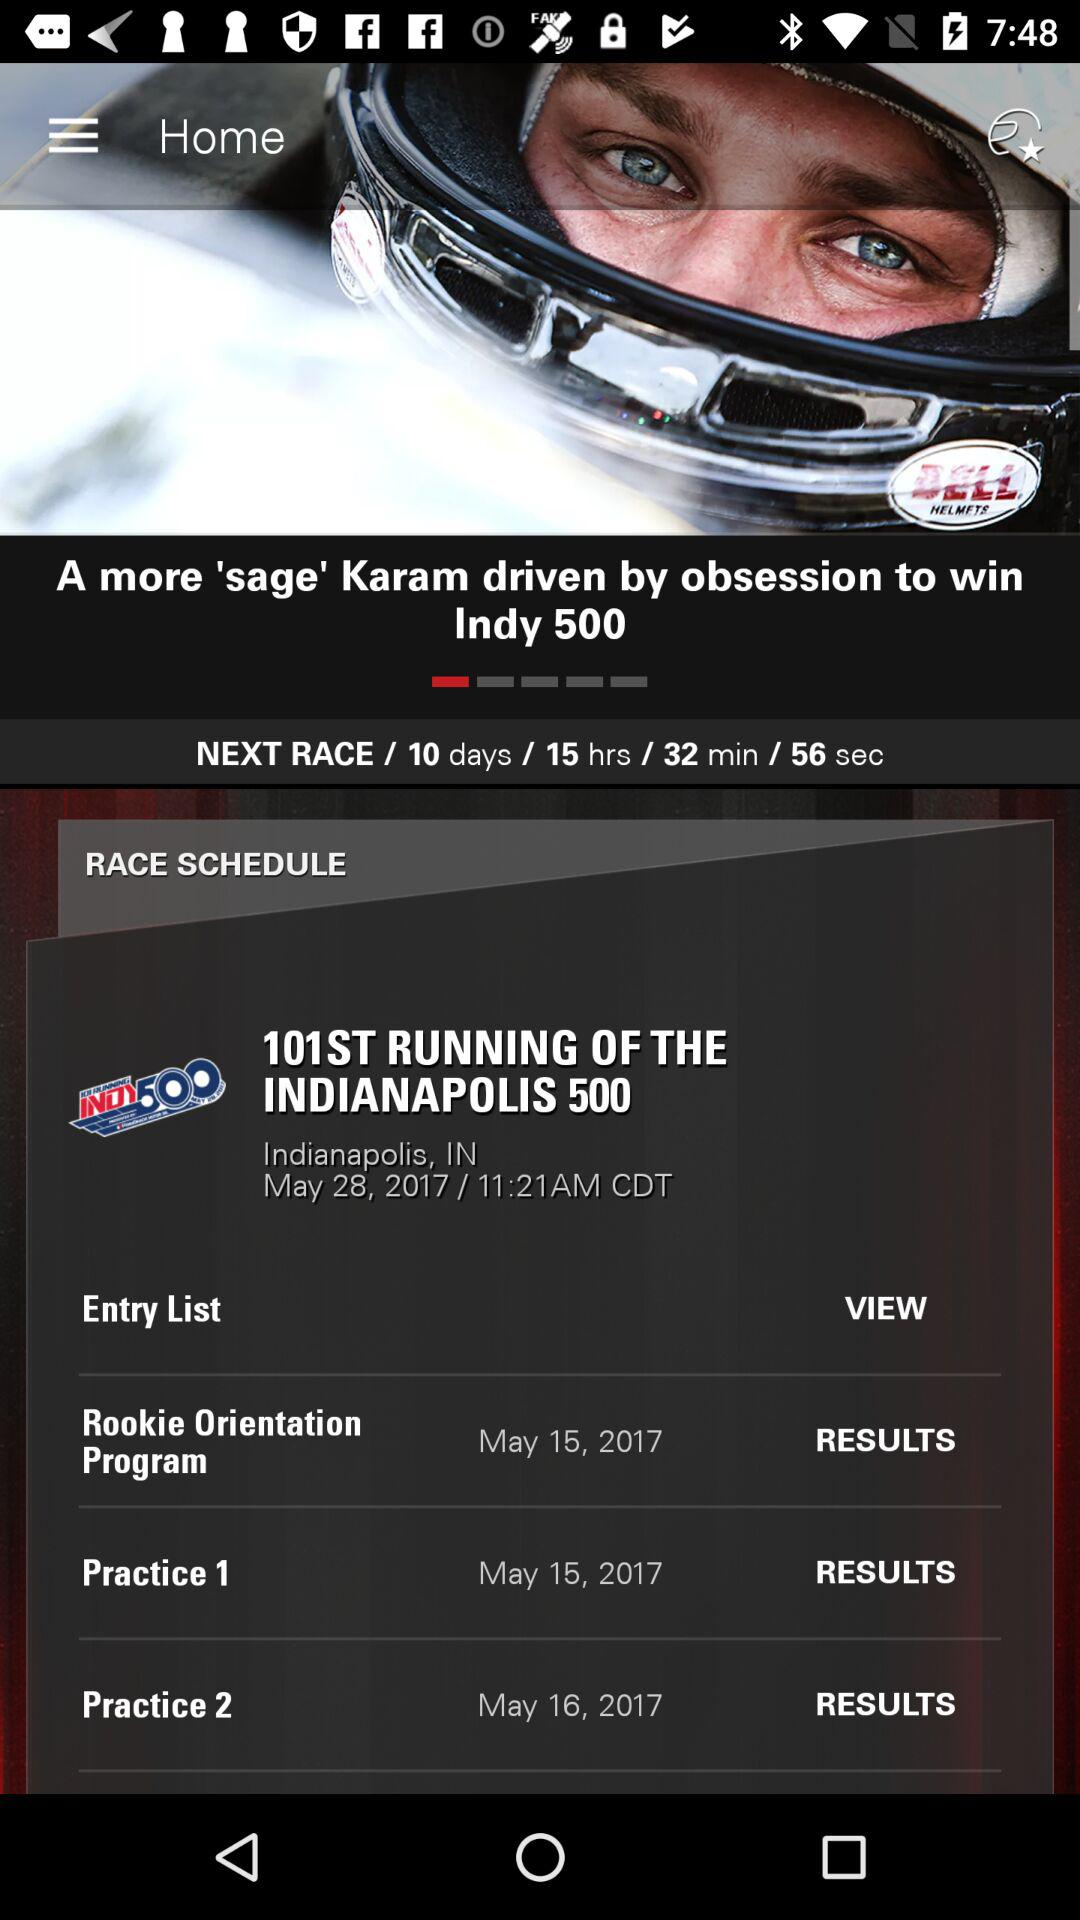On what date did Practice 1 happen? The date is May 15, 2017. 